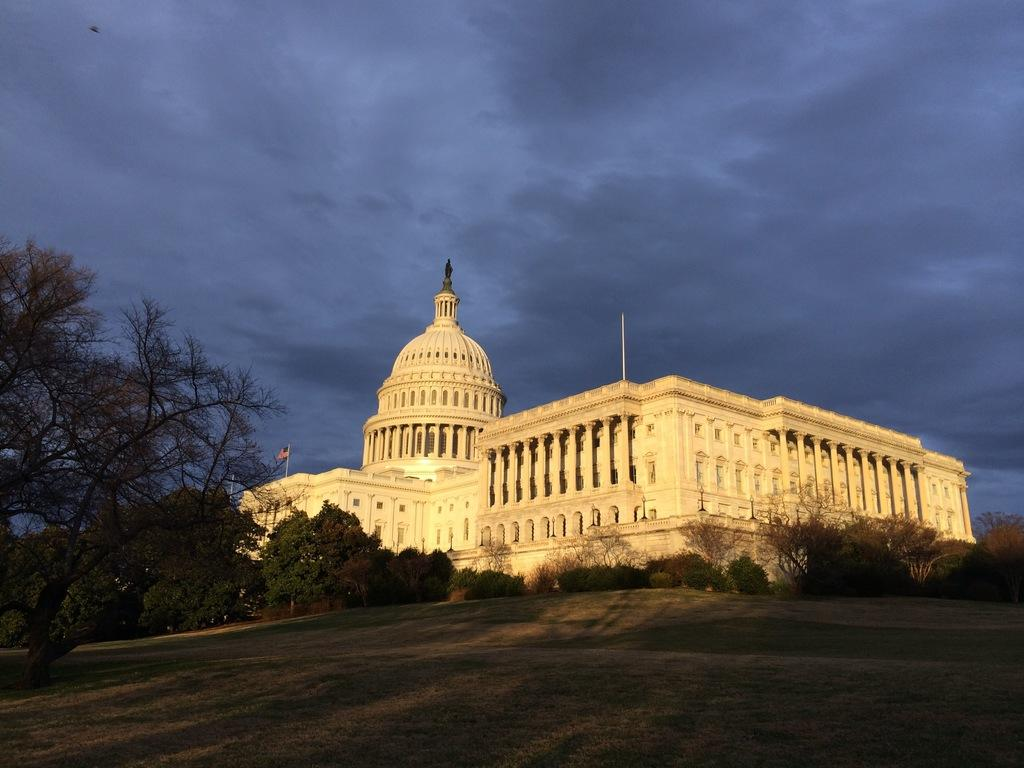What type of building is in the image? There is a palace in the image. What can be seen in front of the palace? Trees are present in front of the palace. What is visible on the ground in the image? The land is visible in the image. What is visible above the palace in the image? The sky is visible in the image. What can be seen in the sky in the image? Clouds are present in the sky. What type of caption is written on the chalkboard near the palace? There is no chalkboard or caption present in the image. How do the waves interact with the palace in the image? There are no waves present in the image; it features a palace, trees, land, sky, and clouds. 